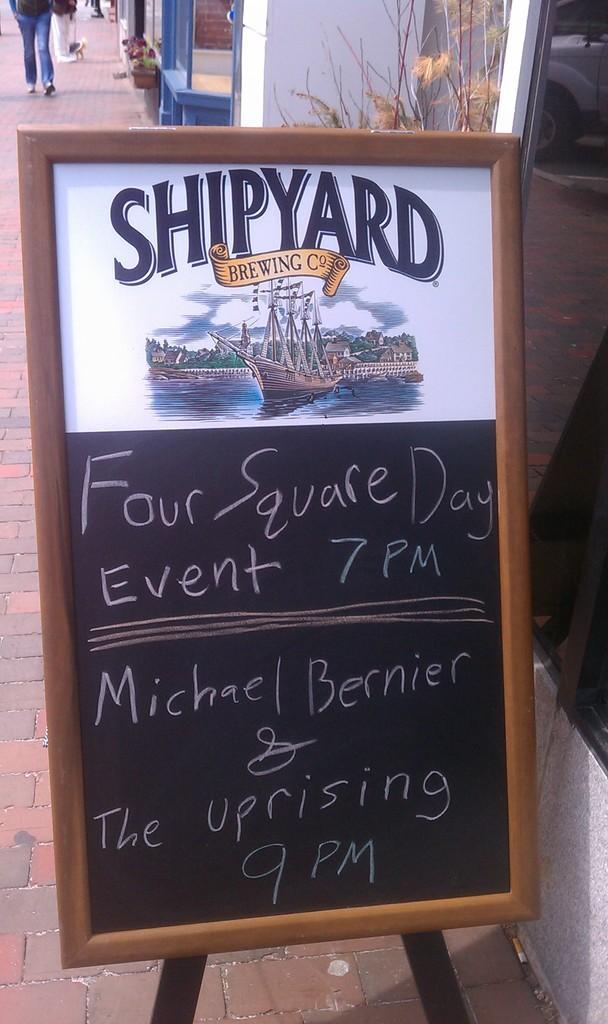Please provide a concise description of this image. This picture is clicked outside. In the foreground we can see the text, numbers and the picture of a boat in the water body and some other pictures on the board. In the background we can see the pavement, leaves ,group of persons and building and some other objects. 